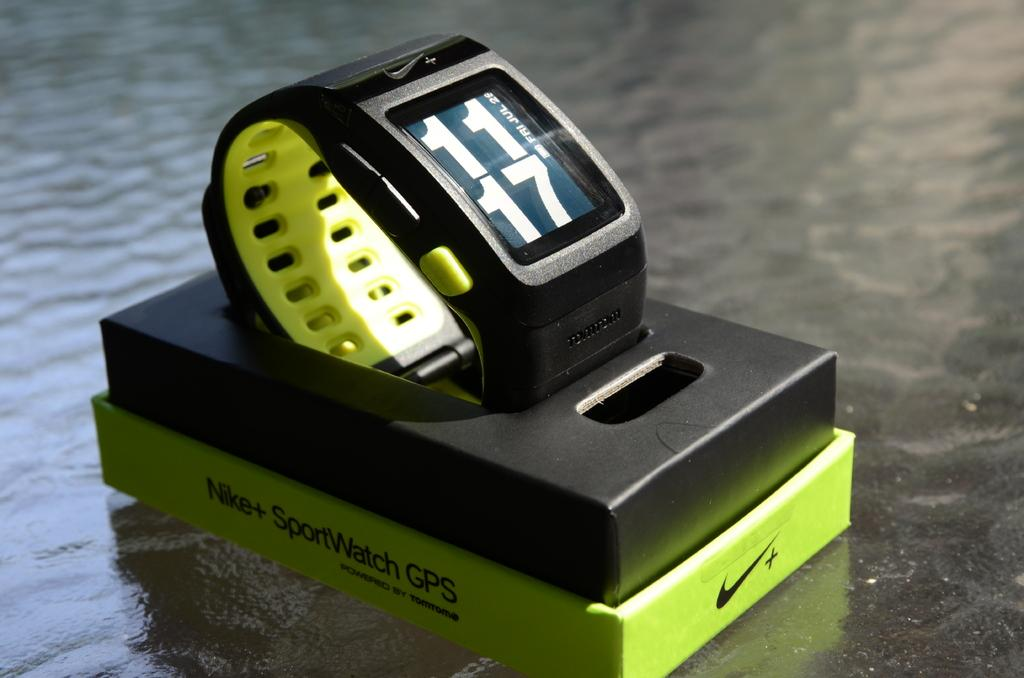<image>
Give a short and clear explanation of the subsequent image. Black and green sports watch that says the time is 11:17. 